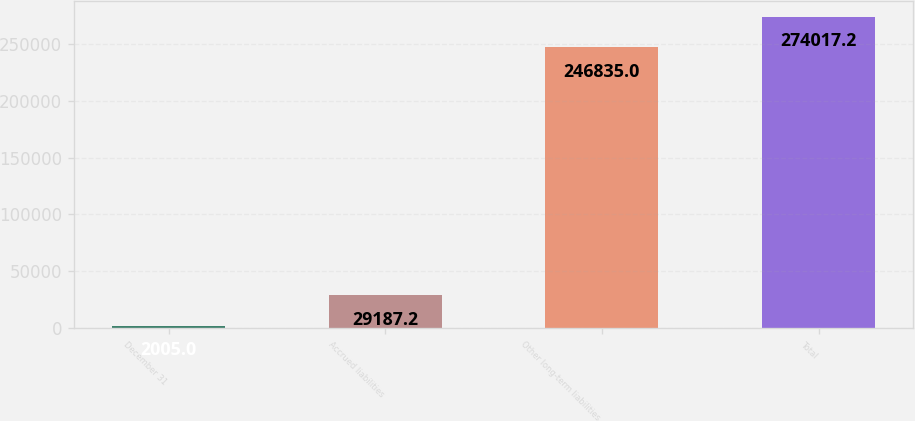Convert chart. <chart><loc_0><loc_0><loc_500><loc_500><bar_chart><fcel>December 31<fcel>Accrued liabilities<fcel>Other long-term liabilities<fcel>Total<nl><fcel>2005<fcel>29187.2<fcel>246835<fcel>274017<nl></chart> 